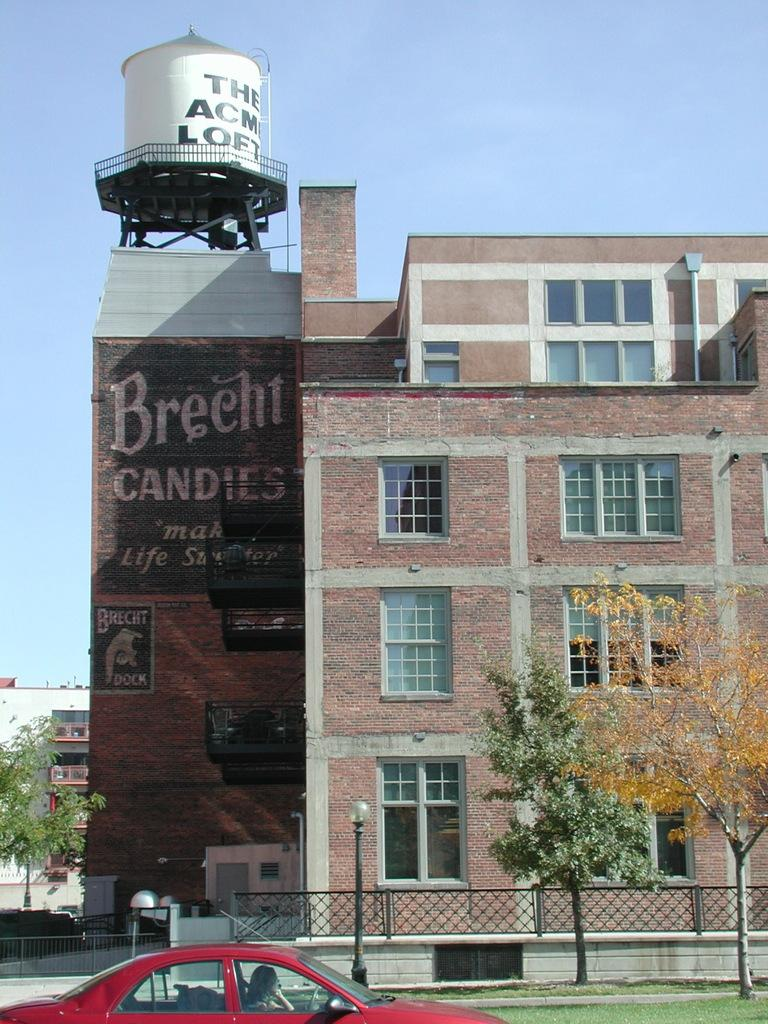What type of structures can be seen in the image? There are buildings in the image. What is located above the buildings? There is an overhead tank in the image. What are the long, tubular structures visible in the image? Pipelines are visible in the image. What can be seen on the buildings in the image? There are windows in the image. What are the tall, vertical structures present in the image? Street poles are present in the image. What are the light sources visible in the image? Street lights are visible in the image. What type of barrier is present in the image? There is an iron grill in the image. What is visible at the bottom of the image? The ground is visible in the image. What type of vehicle is present in the image? A motor vehicle is present in the image. What type of vegetation is visible in the image? Trees are in the image. What is visible in the top part of the image? The sky is visible in the image. What type of tin can be seen in the image? There is no tin present in the image. What color is the gold in the image? There is no gold present in the image. How many birds are perched on the street poles in the image? There are no birds present in the image. 